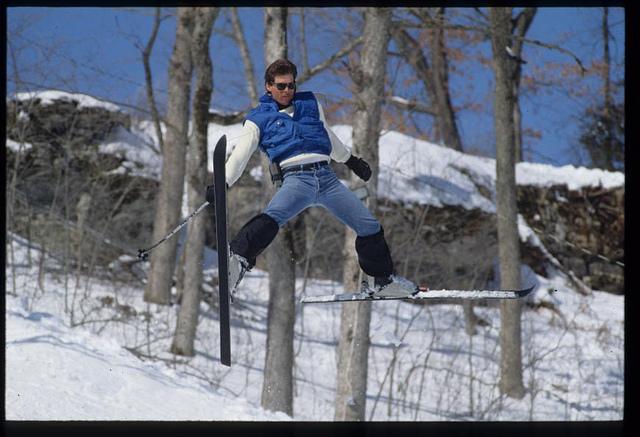Is the man standing on the trees?
Give a very brief answer. No. Where is the blue vest?
Give a very brief answer. On man. Is this the man's first type on skis?
Write a very short answer. No. What color is the photo?
Concise answer only. Mostly white. What are the black things on his legs called?
Answer briefly. Leg warmers. 